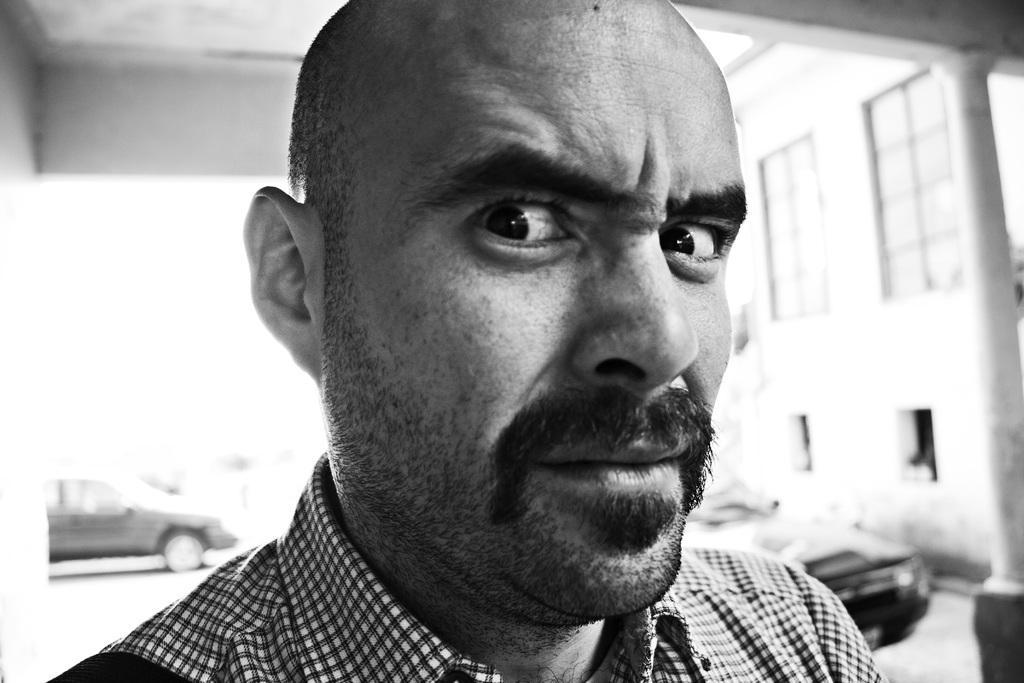Could you give a brief overview of what you see in this image? This picture shows a man standing and we see a building and couple of cars. 